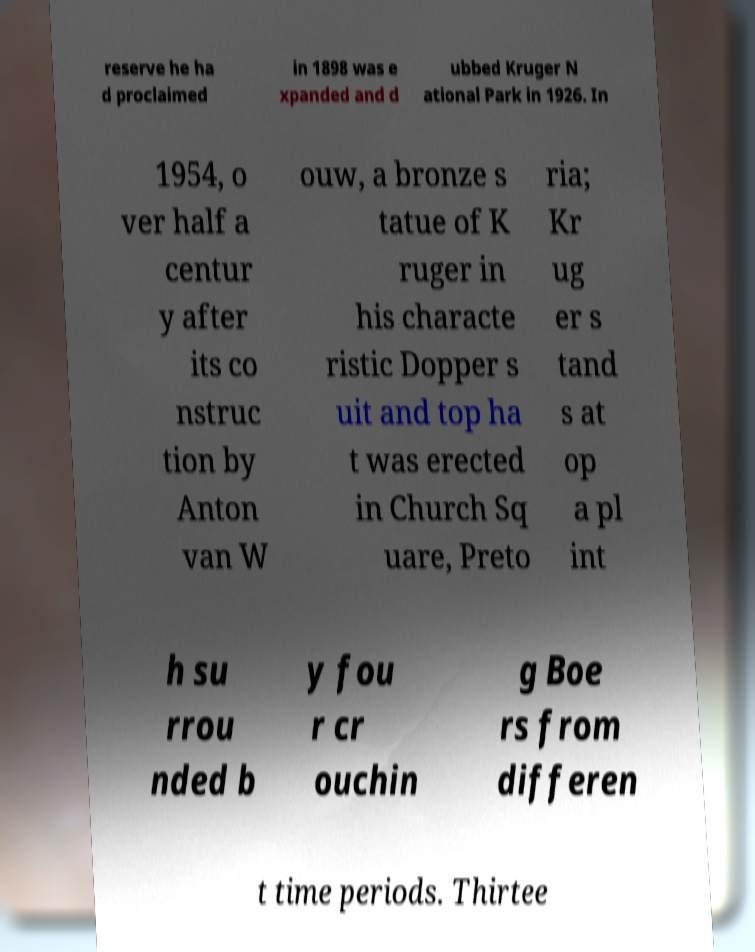Please read and relay the text visible in this image. What does it say? reserve he ha d proclaimed in 1898 was e xpanded and d ubbed Kruger N ational Park in 1926. In 1954, o ver half a centur y after its co nstruc tion by Anton van W ouw, a bronze s tatue of K ruger in his characte ristic Dopper s uit and top ha t was erected in Church Sq uare, Preto ria; Kr ug er s tand s at op a pl int h su rrou nded b y fou r cr ouchin g Boe rs from differen t time periods. Thirtee 